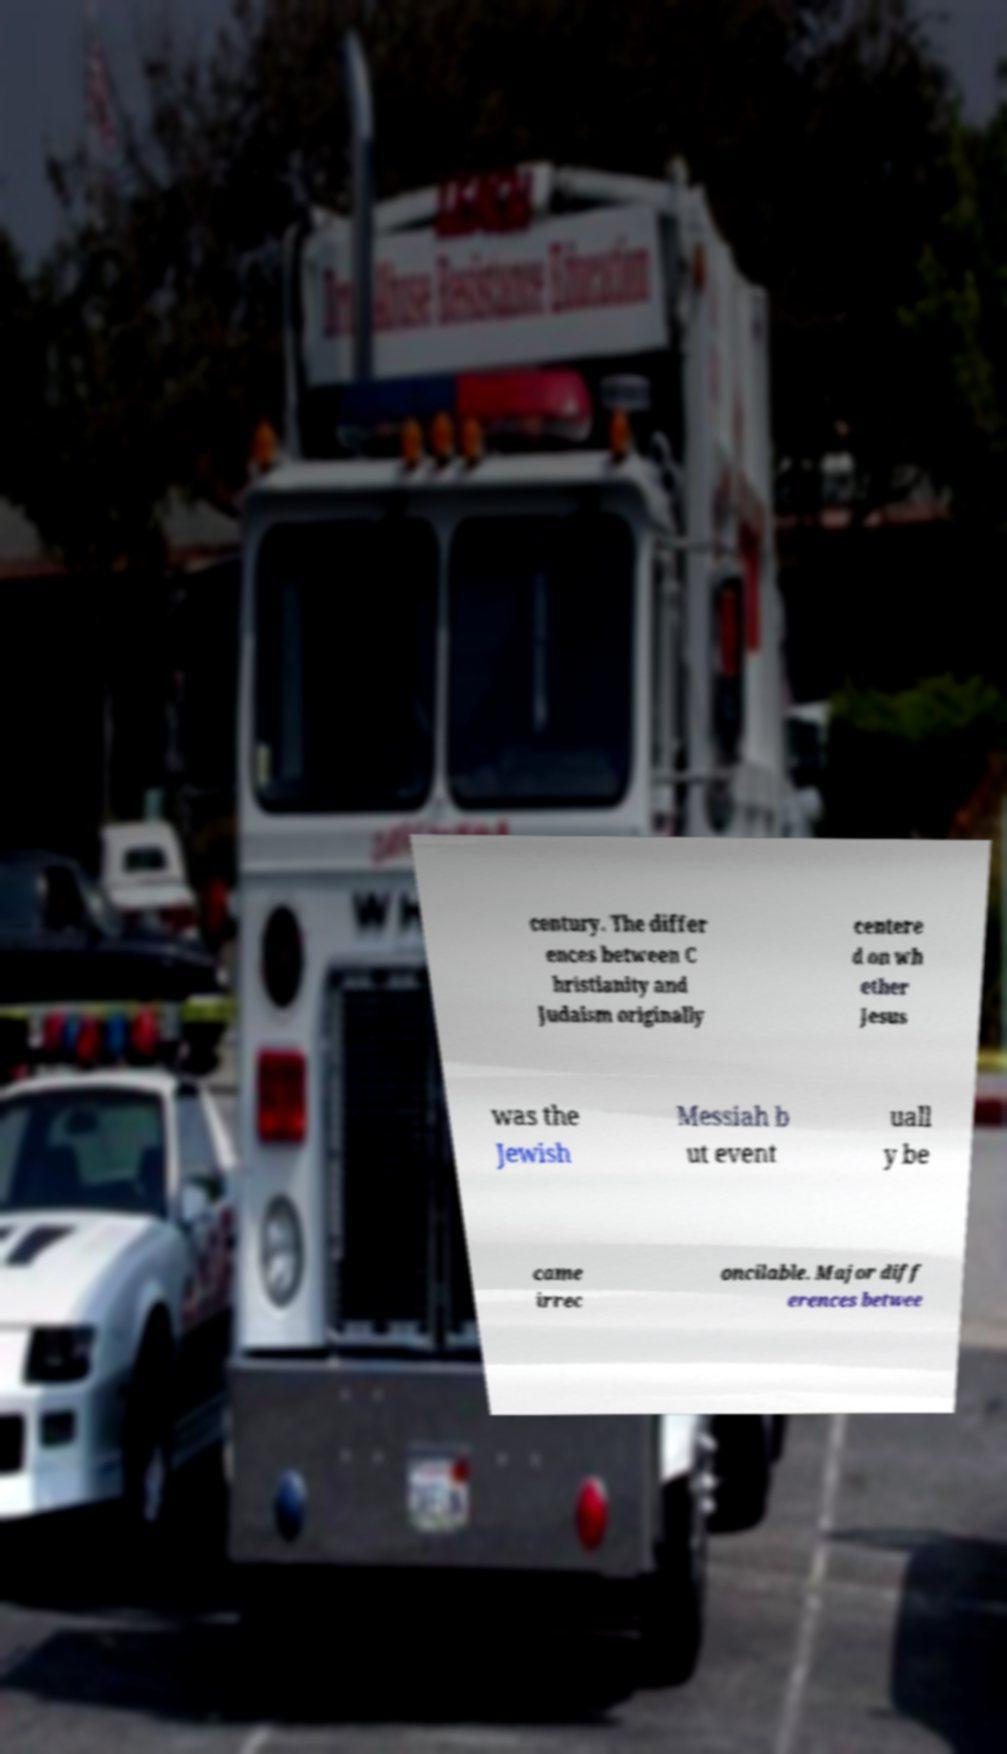I need the written content from this picture converted into text. Can you do that? century. The differ ences between C hristianity and Judaism originally centere d on wh ether Jesus was the Jewish Messiah b ut event uall y be came irrec oncilable. Major diff erences betwee 